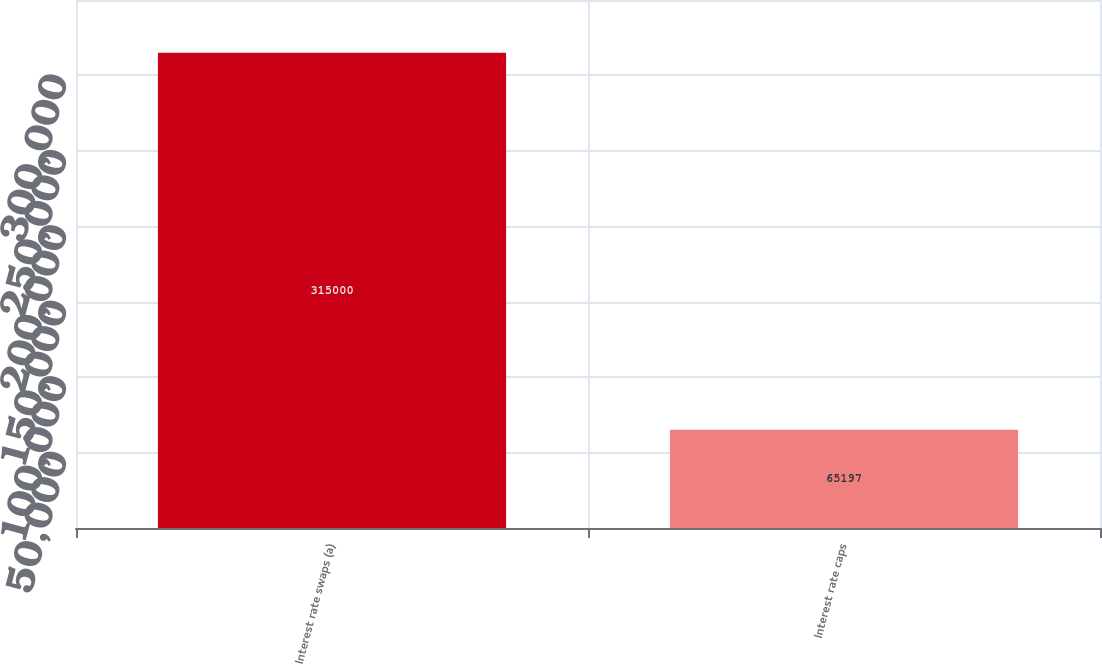Convert chart to OTSL. <chart><loc_0><loc_0><loc_500><loc_500><bar_chart><fcel>Interest rate swaps (a)<fcel>Interest rate caps<nl><fcel>315000<fcel>65197<nl></chart> 